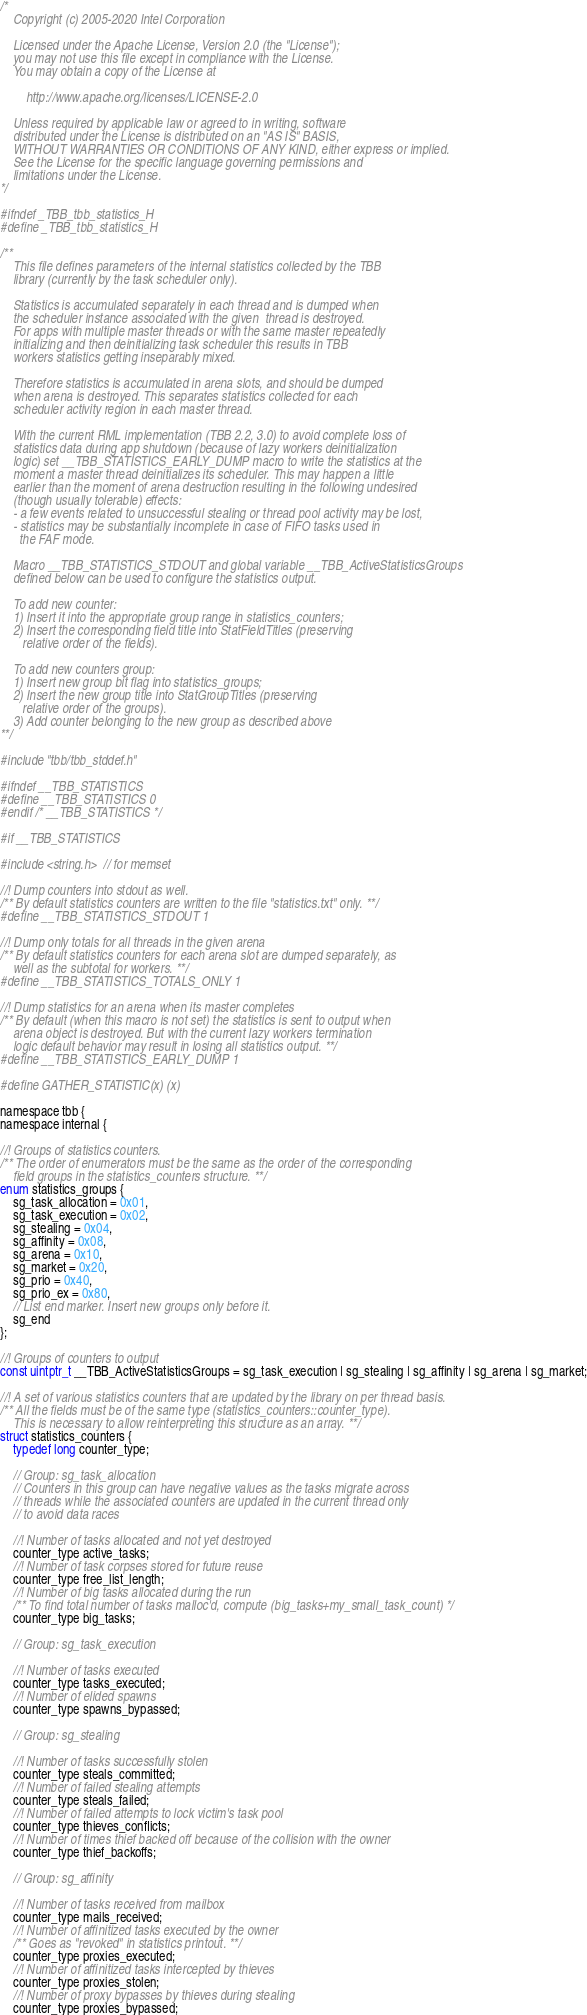Convert code to text. <code><loc_0><loc_0><loc_500><loc_500><_C_>/*
    Copyright (c) 2005-2020 Intel Corporation

    Licensed under the Apache License, Version 2.0 (the "License");
    you may not use this file except in compliance with the License.
    You may obtain a copy of the License at

        http://www.apache.org/licenses/LICENSE-2.0

    Unless required by applicable law or agreed to in writing, software
    distributed under the License is distributed on an "AS IS" BASIS,
    WITHOUT WARRANTIES OR CONDITIONS OF ANY KIND, either express or implied.
    See the License for the specific language governing permissions and
    limitations under the License.
*/

#ifndef _TBB_tbb_statistics_H
#define _TBB_tbb_statistics_H

/**
    This file defines parameters of the internal statistics collected by the TBB
    library (currently by the task scheduler only).

    Statistics is accumulated separately in each thread and is dumped when
    the scheduler instance associated with the given  thread is destroyed.
    For apps with multiple master threads or with the same master repeatedly
    initializing and then deinitializing task scheduler this results in TBB
    workers statistics getting inseparably mixed.

    Therefore statistics is accumulated in arena slots, and should be dumped
    when arena is destroyed. This separates statistics collected for each
    scheduler activity region in each master thread.

    With the current RML implementation (TBB 2.2, 3.0) to avoid complete loss of
    statistics data during app shutdown (because of lazy workers deinitialization
    logic) set __TBB_STATISTICS_EARLY_DUMP macro to write the statistics at the
    moment a master thread deinitializes its scheduler. This may happen a little
    earlier than the moment of arena destruction resulting in the following undesired
    (though usually tolerable) effects:
    - a few events related to unsuccessful stealing or thread pool activity may be lost,
    - statistics may be substantially incomplete in case of FIFO tasks used in
      the FAF mode.

    Macro __TBB_STATISTICS_STDOUT and global variable __TBB_ActiveStatisticsGroups
    defined below can be used to configure the statistics output.

    To add new counter:
    1) Insert it into the appropriate group range in statistics_counters;
    2) Insert the corresponding field title into StatFieldTitles (preserving
       relative order of the fields).

    To add new counters group:
    1) Insert new group bit flag into statistics_groups;
    2) Insert the new group title into StatGroupTitles (preserving
       relative order of the groups).
    3) Add counter belonging to the new group as described above
**/

#include "tbb/tbb_stddef.h"

#ifndef __TBB_STATISTICS
#define __TBB_STATISTICS 0
#endif /* __TBB_STATISTICS */

#if __TBB_STATISTICS

#include <string.h>  // for memset

//! Dump counters into stdout as well.
/** By default statistics counters are written to the file "statistics.txt" only. **/
#define __TBB_STATISTICS_STDOUT 1

//! Dump only totals for all threads in the given arena
/** By default statistics counters for each arena slot are dumped separately, as
    well as the subtotal for workers. **/
#define __TBB_STATISTICS_TOTALS_ONLY 1

//! Dump statistics for an arena when its master completes
/** By default (when this macro is not set) the statistics is sent to output when
    arena object is destroyed. But with the current lazy workers termination
    logic default behavior may result in losing all statistics output. **/
#define __TBB_STATISTICS_EARLY_DUMP 1

#define GATHER_STATISTIC(x) (x)

namespace tbb {
namespace internal {

//! Groups of statistics counters.
/** The order of enumerators must be the same as the order of the corresponding
    field groups in the statistics_counters structure. **/
enum statistics_groups {
    sg_task_allocation = 0x01,
    sg_task_execution = 0x02,
    sg_stealing = 0x04,
    sg_affinity = 0x08,
    sg_arena = 0x10,
    sg_market = 0x20,
    sg_prio = 0x40,
    sg_prio_ex = 0x80,
    // List end marker. Insert new groups only before it.
    sg_end
};

//! Groups of counters to output
const uintptr_t __TBB_ActiveStatisticsGroups = sg_task_execution | sg_stealing | sg_affinity | sg_arena | sg_market;

//! A set of various statistics counters that are updated by the library on per thread basis.
/** All the fields must be of the same type (statistics_counters::counter_type).
    This is necessary to allow reinterpreting this structure as an array. **/
struct statistics_counters {
    typedef long counter_type;

    // Group: sg_task_allocation
    // Counters in this group can have negative values as the tasks migrate across
    // threads while the associated counters are updated in the current thread only
    // to avoid data races

    //! Number of tasks allocated and not yet destroyed
    counter_type active_tasks;
    //! Number of task corpses stored for future reuse
    counter_type free_list_length;
    //! Number of big tasks allocated during the run
    /** To find total number of tasks malloc'd, compute (big_tasks+my_small_task_count) */
    counter_type big_tasks;

    // Group: sg_task_execution

    //! Number of tasks executed
    counter_type tasks_executed;
    //! Number of elided spawns
    counter_type spawns_bypassed;

    // Group: sg_stealing

    //! Number of tasks successfully stolen
    counter_type steals_committed;
    //! Number of failed stealing attempts
    counter_type steals_failed;
    //! Number of failed attempts to lock victim's task pool
    counter_type thieves_conflicts;
    //! Number of times thief backed off because of the collision with the owner
    counter_type thief_backoffs;

    // Group: sg_affinity

    //! Number of tasks received from mailbox
    counter_type mails_received;
    //! Number of affinitized tasks executed by the owner
    /** Goes as "revoked" in statistics printout. **/
    counter_type proxies_executed;
    //! Number of affinitized tasks intercepted by thieves
    counter_type proxies_stolen;
    //! Number of proxy bypasses by thieves during stealing
    counter_type proxies_bypassed;</code> 